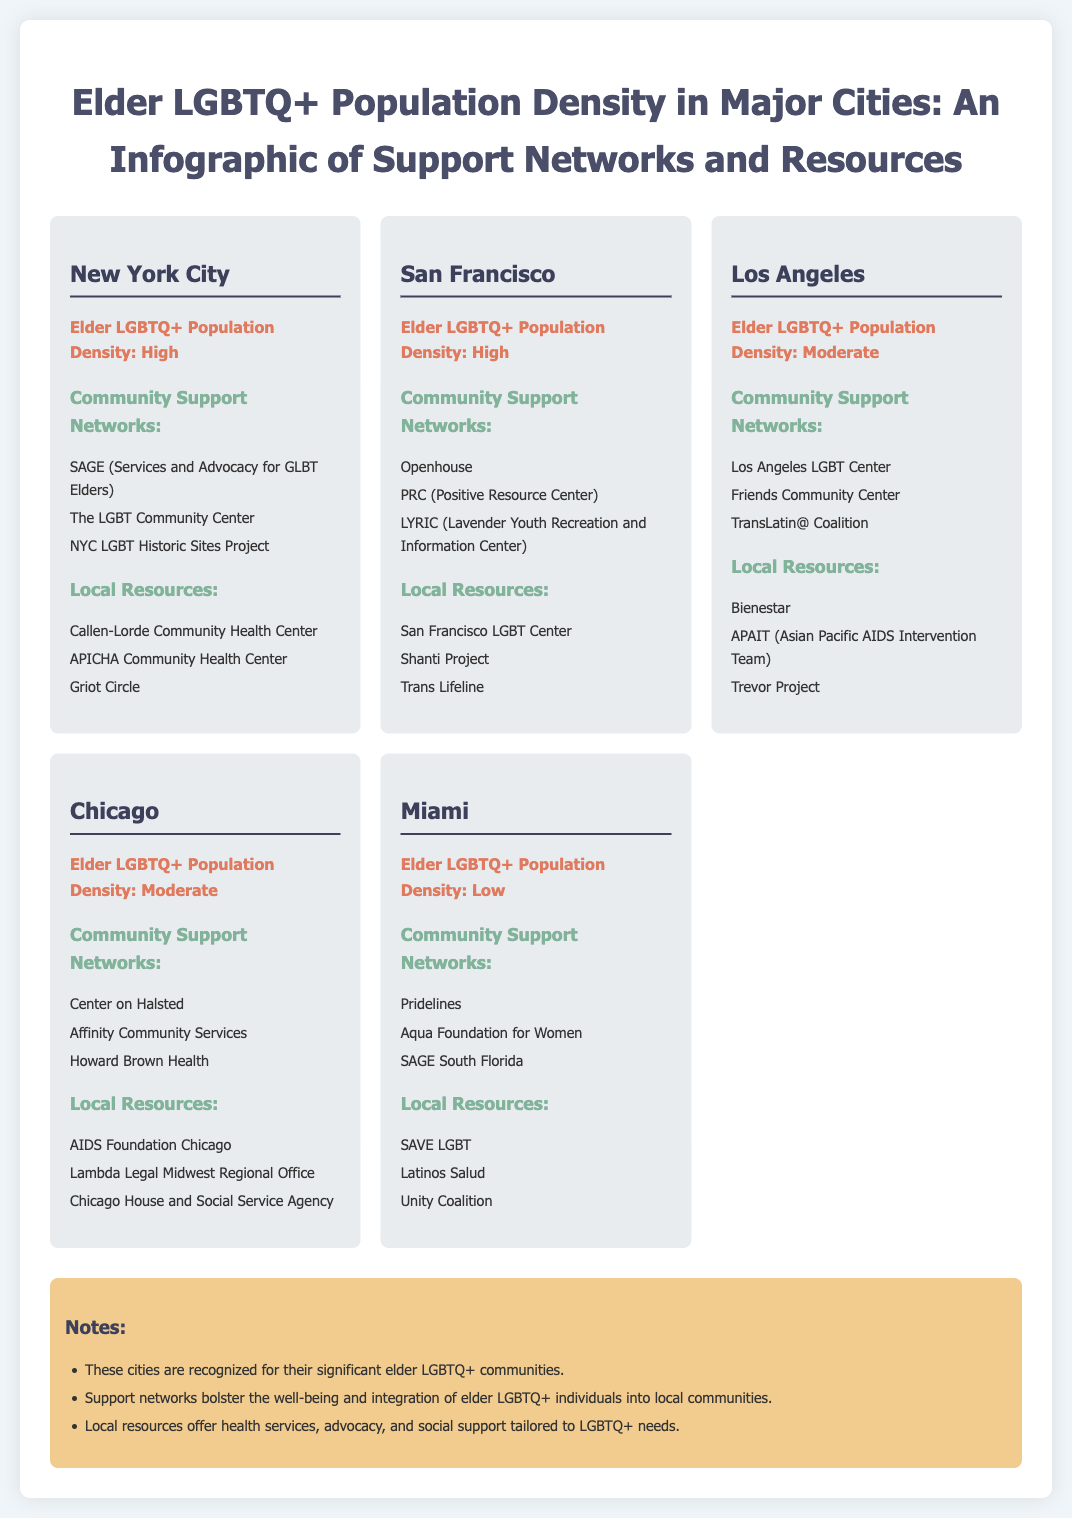what is the elder LGBTQ+ population density in New York City? The document states that New York City has a high elder LGBTQ+ population density.
Answer: High which city has the lowest elder LGBTQ+ population density? According to the infographic, Miami has the lowest elder LGBTQ+ population density.
Answer: Miami name a community support network listed for San Francisco. The document includes Openhouse as a community support network for San Francisco.
Answer: Openhouse how many local resources are listed for Los Angeles? The document specifies three local resources for Los Angeles.
Answer: Three which city has the highest concentration of elder LGBTQ+ population? The infographic identifies New York City and San Francisco as having a high concentration.
Answer: New York City and San Francisco what organization is mentioned as a local resource in Miami? The document lists SAVE LGBT as a local resource in Miami.
Answer: SAVE LGBT which city is associated with the organization "Center on Halsted"? The Center on Halsted is associated with Chicago according to the infographic.
Answer: Chicago what support network is mentioned for elderly LGBTQ+ individuals in Los Angeles? The document mentions the Los Angeles LGBT Center as a support network.
Answer: Los Angeles LGBT Center how many cities are highlighted in the infographic? The document highlights five major cities regarding elder LGBTQ+ population density.
Answer: Five 